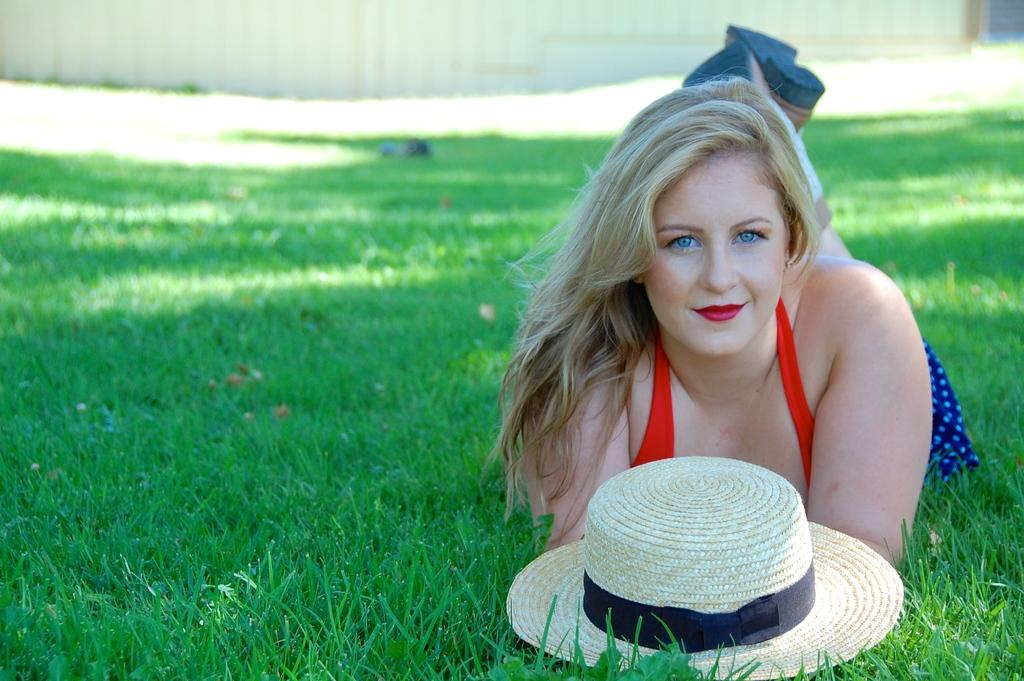What is the girl doing in the image? The girl is lying on the grass in the image. What object is in front of the girl? The girl has a hat in front of her. What can be seen in the background of the image? There might be a fencing wall of a building in the background of the image. What type of bean is being discussed by the girl in the image? There is no bean or discussion about a bean present in the image. 